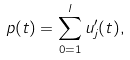Convert formula to latex. <formula><loc_0><loc_0><loc_500><loc_500>p ( t ) = \sum _ { 0 = 1 } ^ { l } u ^ { \prime } _ { j } ( t ) ,</formula> 